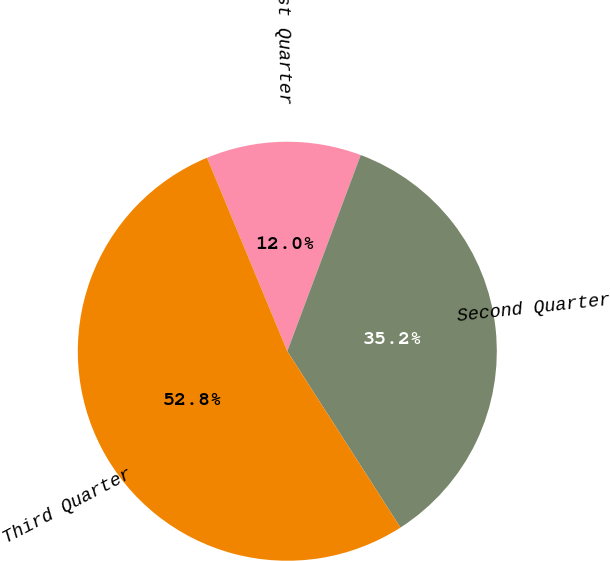<chart> <loc_0><loc_0><loc_500><loc_500><pie_chart><fcel>First Quarter<fcel>Second Quarter<fcel>Third Quarter<nl><fcel>11.96%<fcel>35.22%<fcel>52.82%<nl></chart> 